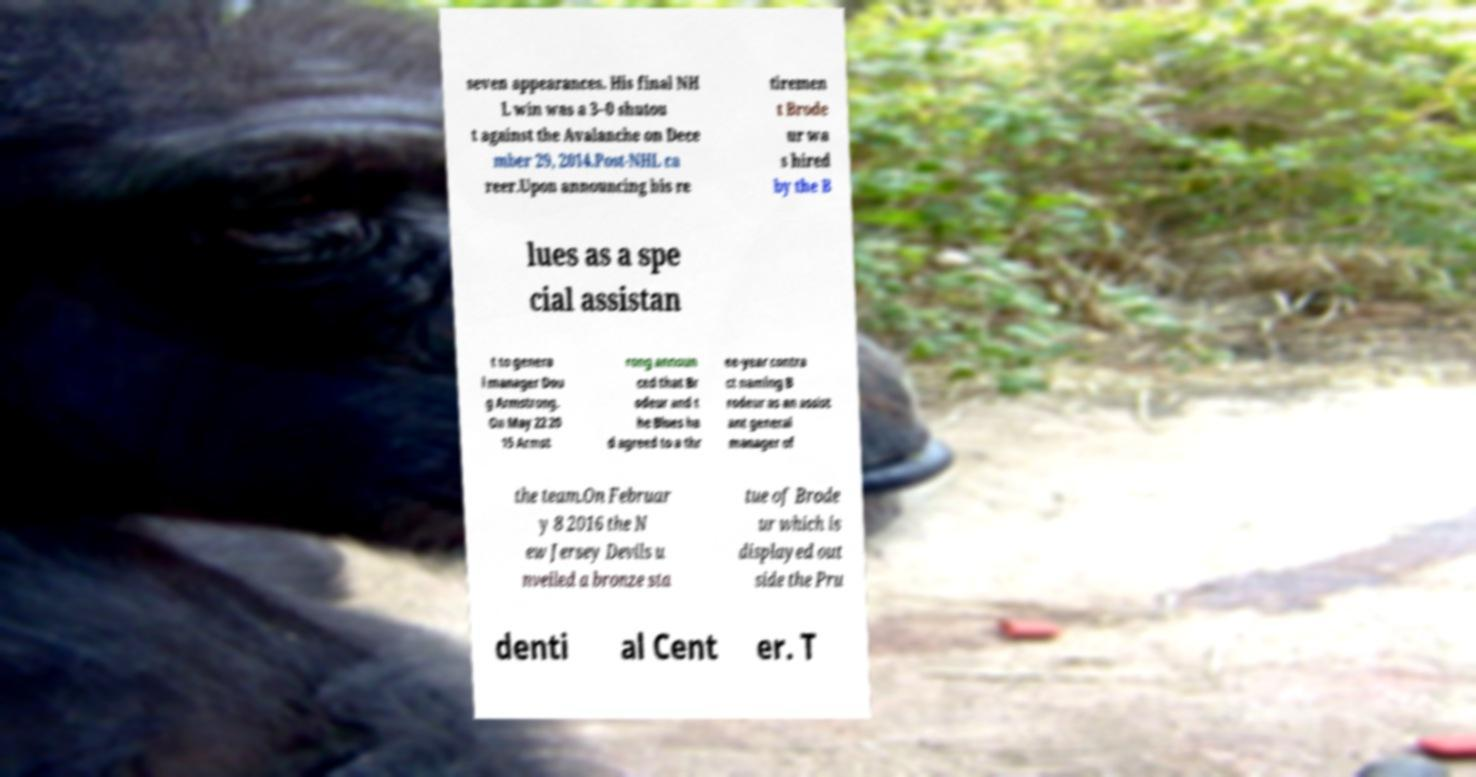There's text embedded in this image that I need extracted. Can you transcribe it verbatim? seven appearances. His final NH L win was a 3–0 shutou t against the Avalanche on Dece mber 29, 2014.Post-NHL ca reer.Upon announcing his re tiremen t Brode ur wa s hired by the B lues as a spe cial assistan t to genera l manager Dou g Armstrong. On May 22 20 15 Armst rong announ ced that Br odeur and t he Blues ha d agreed to a thr ee-year contra ct naming B rodeur as an assist ant general manager of the team.On Februar y 8 2016 the N ew Jersey Devils u nveiled a bronze sta tue of Brode ur which is displayed out side the Pru denti al Cent er. T 